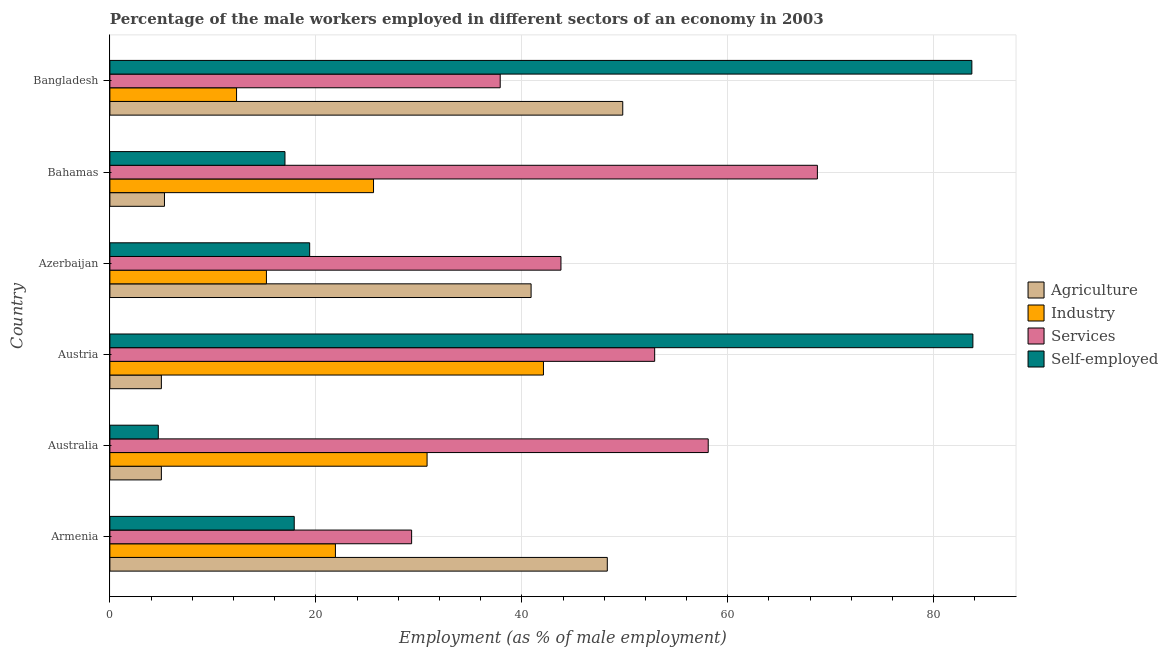How many different coloured bars are there?
Provide a succinct answer. 4. How many groups of bars are there?
Give a very brief answer. 6. Are the number of bars on each tick of the Y-axis equal?
Offer a terse response. Yes. What is the label of the 4th group of bars from the top?
Offer a terse response. Austria. What is the percentage of self employed male workers in Austria?
Your answer should be compact. 83.8. Across all countries, what is the maximum percentage of male workers in services?
Your response must be concise. 68.7. Across all countries, what is the minimum percentage of male workers in industry?
Your answer should be very brief. 12.3. In which country was the percentage of male workers in services maximum?
Keep it short and to the point. Bahamas. What is the total percentage of self employed male workers in the graph?
Offer a very short reply. 226.5. What is the difference between the percentage of self employed male workers in Australia and that in Azerbaijan?
Make the answer very short. -14.7. What is the difference between the percentage of male workers in agriculture in Austria and the percentage of male workers in services in Azerbaijan?
Your answer should be compact. -38.8. What is the average percentage of male workers in services per country?
Offer a very short reply. 48.45. What is the difference between the percentage of male workers in services and percentage of male workers in industry in Bahamas?
Offer a terse response. 43.1. What is the ratio of the percentage of male workers in industry in Austria to that in Azerbaijan?
Your response must be concise. 2.77. Is the difference between the percentage of self employed male workers in Australia and Austria greater than the difference between the percentage of male workers in industry in Australia and Austria?
Make the answer very short. No. What is the difference between the highest and the second highest percentage of male workers in industry?
Offer a very short reply. 11.3. What is the difference between the highest and the lowest percentage of male workers in industry?
Give a very brief answer. 29.8. What does the 2nd bar from the top in Azerbaijan represents?
Give a very brief answer. Services. What does the 1st bar from the bottom in Armenia represents?
Your response must be concise. Agriculture. Is it the case that in every country, the sum of the percentage of male workers in agriculture and percentage of male workers in industry is greater than the percentage of male workers in services?
Your answer should be very brief. No. How many bars are there?
Provide a succinct answer. 24. What is the difference between two consecutive major ticks on the X-axis?
Provide a short and direct response. 20. Are the values on the major ticks of X-axis written in scientific E-notation?
Offer a very short reply. No. Does the graph contain grids?
Keep it short and to the point. Yes. Where does the legend appear in the graph?
Your answer should be very brief. Center right. How are the legend labels stacked?
Your answer should be compact. Vertical. What is the title of the graph?
Your answer should be compact. Percentage of the male workers employed in different sectors of an economy in 2003. What is the label or title of the X-axis?
Your answer should be very brief. Employment (as % of male employment). What is the Employment (as % of male employment) of Agriculture in Armenia?
Provide a short and direct response. 48.3. What is the Employment (as % of male employment) of Industry in Armenia?
Make the answer very short. 21.9. What is the Employment (as % of male employment) of Services in Armenia?
Offer a terse response. 29.3. What is the Employment (as % of male employment) in Self-employed in Armenia?
Your response must be concise. 17.9. What is the Employment (as % of male employment) in Agriculture in Australia?
Offer a very short reply. 5. What is the Employment (as % of male employment) of Industry in Australia?
Provide a short and direct response. 30.8. What is the Employment (as % of male employment) of Services in Australia?
Offer a very short reply. 58.1. What is the Employment (as % of male employment) of Self-employed in Australia?
Give a very brief answer. 4.7. What is the Employment (as % of male employment) of Industry in Austria?
Offer a very short reply. 42.1. What is the Employment (as % of male employment) of Services in Austria?
Ensure brevity in your answer.  52.9. What is the Employment (as % of male employment) in Self-employed in Austria?
Give a very brief answer. 83.8. What is the Employment (as % of male employment) in Agriculture in Azerbaijan?
Your answer should be compact. 40.9. What is the Employment (as % of male employment) in Industry in Azerbaijan?
Your answer should be very brief. 15.2. What is the Employment (as % of male employment) of Services in Azerbaijan?
Give a very brief answer. 43.8. What is the Employment (as % of male employment) of Self-employed in Azerbaijan?
Make the answer very short. 19.4. What is the Employment (as % of male employment) in Agriculture in Bahamas?
Provide a succinct answer. 5.3. What is the Employment (as % of male employment) of Industry in Bahamas?
Your answer should be compact. 25.6. What is the Employment (as % of male employment) in Services in Bahamas?
Your answer should be compact. 68.7. What is the Employment (as % of male employment) in Agriculture in Bangladesh?
Your answer should be very brief. 49.8. What is the Employment (as % of male employment) of Industry in Bangladesh?
Keep it short and to the point. 12.3. What is the Employment (as % of male employment) in Services in Bangladesh?
Your answer should be compact. 37.9. What is the Employment (as % of male employment) in Self-employed in Bangladesh?
Offer a terse response. 83.7. Across all countries, what is the maximum Employment (as % of male employment) in Agriculture?
Offer a terse response. 49.8. Across all countries, what is the maximum Employment (as % of male employment) of Industry?
Make the answer very short. 42.1. Across all countries, what is the maximum Employment (as % of male employment) of Services?
Provide a succinct answer. 68.7. Across all countries, what is the maximum Employment (as % of male employment) of Self-employed?
Provide a short and direct response. 83.8. Across all countries, what is the minimum Employment (as % of male employment) of Industry?
Give a very brief answer. 12.3. Across all countries, what is the minimum Employment (as % of male employment) of Services?
Your response must be concise. 29.3. Across all countries, what is the minimum Employment (as % of male employment) in Self-employed?
Offer a terse response. 4.7. What is the total Employment (as % of male employment) in Agriculture in the graph?
Ensure brevity in your answer.  154.3. What is the total Employment (as % of male employment) of Industry in the graph?
Ensure brevity in your answer.  147.9. What is the total Employment (as % of male employment) in Services in the graph?
Ensure brevity in your answer.  290.7. What is the total Employment (as % of male employment) in Self-employed in the graph?
Provide a succinct answer. 226.5. What is the difference between the Employment (as % of male employment) in Agriculture in Armenia and that in Australia?
Your answer should be very brief. 43.3. What is the difference between the Employment (as % of male employment) in Industry in Armenia and that in Australia?
Your response must be concise. -8.9. What is the difference between the Employment (as % of male employment) in Services in Armenia and that in Australia?
Make the answer very short. -28.8. What is the difference between the Employment (as % of male employment) in Agriculture in Armenia and that in Austria?
Your answer should be compact. 43.3. What is the difference between the Employment (as % of male employment) in Industry in Armenia and that in Austria?
Ensure brevity in your answer.  -20.2. What is the difference between the Employment (as % of male employment) in Services in Armenia and that in Austria?
Keep it short and to the point. -23.6. What is the difference between the Employment (as % of male employment) in Self-employed in Armenia and that in Austria?
Keep it short and to the point. -65.9. What is the difference between the Employment (as % of male employment) in Agriculture in Armenia and that in Azerbaijan?
Your answer should be compact. 7.4. What is the difference between the Employment (as % of male employment) in Industry in Armenia and that in Bahamas?
Your answer should be very brief. -3.7. What is the difference between the Employment (as % of male employment) of Services in Armenia and that in Bahamas?
Ensure brevity in your answer.  -39.4. What is the difference between the Employment (as % of male employment) of Self-employed in Armenia and that in Bahamas?
Offer a very short reply. 0.9. What is the difference between the Employment (as % of male employment) of Industry in Armenia and that in Bangladesh?
Make the answer very short. 9.6. What is the difference between the Employment (as % of male employment) of Services in Armenia and that in Bangladesh?
Give a very brief answer. -8.6. What is the difference between the Employment (as % of male employment) of Self-employed in Armenia and that in Bangladesh?
Offer a terse response. -65.8. What is the difference between the Employment (as % of male employment) in Industry in Australia and that in Austria?
Your answer should be compact. -11.3. What is the difference between the Employment (as % of male employment) of Self-employed in Australia and that in Austria?
Offer a very short reply. -79.1. What is the difference between the Employment (as % of male employment) in Agriculture in Australia and that in Azerbaijan?
Your answer should be compact. -35.9. What is the difference between the Employment (as % of male employment) in Services in Australia and that in Azerbaijan?
Give a very brief answer. 14.3. What is the difference between the Employment (as % of male employment) of Self-employed in Australia and that in Azerbaijan?
Keep it short and to the point. -14.7. What is the difference between the Employment (as % of male employment) of Agriculture in Australia and that in Bahamas?
Provide a short and direct response. -0.3. What is the difference between the Employment (as % of male employment) of Self-employed in Australia and that in Bahamas?
Your answer should be very brief. -12.3. What is the difference between the Employment (as % of male employment) in Agriculture in Australia and that in Bangladesh?
Your answer should be very brief. -44.8. What is the difference between the Employment (as % of male employment) in Services in Australia and that in Bangladesh?
Your response must be concise. 20.2. What is the difference between the Employment (as % of male employment) in Self-employed in Australia and that in Bangladesh?
Ensure brevity in your answer.  -79. What is the difference between the Employment (as % of male employment) in Agriculture in Austria and that in Azerbaijan?
Keep it short and to the point. -35.9. What is the difference between the Employment (as % of male employment) of Industry in Austria and that in Azerbaijan?
Offer a terse response. 26.9. What is the difference between the Employment (as % of male employment) in Self-employed in Austria and that in Azerbaijan?
Your response must be concise. 64.4. What is the difference between the Employment (as % of male employment) of Agriculture in Austria and that in Bahamas?
Ensure brevity in your answer.  -0.3. What is the difference between the Employment (as % of male employment) in Services in Austria and that in Bahamas?
Your answer should be compact. -15.8. What is the difference between the Employment (as % of male employment) in Self-employed in Austria and that in Bahamas?
Provide a succinct answer. 66.8. What is the difference between the Employment (as % of male employment) in Agriculture in Austria and that in Bangladesh?
Your answer should be compact. -44.8. What is the difference between the Employment (as % of male employment) of Industry in Austria and that in Bangladesh?
Keep it short and to the point. 29.8. What is the difference between the Employment (as % of male employment) of Agriculture in Azerbaijan and that in Bahamas?
Provide a succinct answer. 35.6. What is the difference between the Employment (as % of male employment) in Services in Azerbaijan and that in Bahamas?
Make the answer very short. -24.9. What is the difference between the Employment (as % of male employment) in Self-employed in Azerbaijan and that in Bahamas?
Provide a succinct answer. 2.4. What is the difference between the Employment (as % of male employment) of Agriculture in Azerbaijan and that in Bangladesh?
Keep it short and to the point. -8.9. What is the difference between the Employment (as % of male employment) of Self-employed in Azerbaijan and that in Bangladesh?
Give a very brief answer. -64.3. What is the difference between the Employment (as % of male employment) of Agriculture in Bahamas and that in Bangladesh?
Your answer should be very brief. -44.5. What is the difference between the Employment (as % of male employment) in Industry in Bahamas and that in Bangladesh?
Offer a very short reply. 13.3. What is the difference between the Employment (as % of male employment) in Services in Bahamas and that in Bangladesh?
Keep it short and to the point. 30.8. What is the difference between the Employment (as % of male employment) in Self-employed in Bahamas and that in Bangladesh?
Ensure brevity in your answer.  -66.7. What is the difference between the Employment (as % of male employment) of Agriculture in Armenia and the Employment (as % of male employment) of Industry in Australia?
Make the answer very short. 17.5. What is the difference between the Employment (as % of male employment) of Agriculture in Armenia and the Employment (as % of male employment) of Services in Australia?
Give a very brief answer. -9.8. What is the difference between the Employment (as % of male employment) in Agriculture in Armenia and the Employment (as % of male employment) in Self-employed in Australia?
Provide a succinct answer. 43.6. What is the difference between the Employment (as % of male employment) of Industry in Armenia and the Employment (as % of male employment) of Services in Australia?
Ensure brevity in your answer.  -36.2. What is the difference between the Employment (as % of male employment) of Services in Armenia and the Employment (as % of male employment) of Self-employed in Australia?
Offer a very short reply. 24.6. What is the difference between the Employment (as % of male employment) in Agriculture in Armenia and the Employment (as % of male employment) in Industry in Austria?
Your response must be concise. 6.2. What is the difference between the Employment (as % of male employment) of Agriculture in Armenia and the Employment (as % of male employment) of Services in Austria?
Make the answer very short. -4.6. What is the difference between the Employment (as % of male employment) of Agriculture in Armenia and the Employment (as % of male employment) of Self-employed in Austria?
Offer a terse response. -35.5. What is the difference between the Employment (as % of male employment) in Industry in Armenia and the Employment (as % of male employment) in Services in Austria?
Provide a succinct answer. -31. What is the difference between the Employment (as % of male employment) in Industry in Armenia and the Employment (as % of male employment) in Self-employed in Austria?
Provide a succinct answer. -61.9. What is the difference between the Employment (as % of male employment) of Services in Armenia and the Employment (as % of male employment) of Self-employed in Austria?
Give a very brief answer. -54.5. What is the difference between the Employment (as % of male employment) of Agriculture in Armenia and the Employment (as % of male employment) of Industry in Azerbaijan?
Your answer should be very brief. 33.1. What is the difference between the Employment (as % of male employment) in Agriculture in Armenia and the Employment (as % of male employment) in Services in Azerbaijan?
Provide a succinct answer. 4.5. What is the difference between the Employment (as % of male employment) of Agriculture in Armenia and the Employment (as % of male employment) of Self-employed in Azerbaijan?
Make the answer very short. 28.9. What is the difference between the Employment (as % of male employment) in Industry in Armenia and the Employment (as % of male employment) in Services in Azerbaijan?
Offer a very short reply. -21.9. What is the difference between the Employment (as % of male employment) of Industry in Armenia and the Employment (as % of male employment) of Self-employed in Azerbaijan?
Provide a succinct answer. 2.5. What is the difference between the Employment (as % of male employment) of Services in Armenia and the Employment (as % of male employment) of Self-employed in Azerbaijan?
Offer a very short reply. 9.9. What is the difference between the Employment (as % of male employment) in Agriculture in Armenia and the Employment (as % of male employment) in Industry in Bahamas?
Your answer should be compact. 22.7. What is the difference between the Employment (as % of male employment) of Agriculture in Armenia and the Employment (as % of male employment) of Services in Bahamas?
Provide a succinct answer. -20.4. What is the difference between the Employment (as % of male employment) in Agriculture in Armenia and the Employment (as % of male employment) in Self-employed in Bahamas?
Ensure brevity in your answer.  31.3. What is the difference between the Employment (as % of male employment) of Industry in Armenia and the Employment (as % of male employment) of Services in Bahamas?
Your answer should be compact. -46.8. What is the difference between the Employment (as % of male employment) in Industry in Armenia and the Employment (as % of male employment) in Self-employed in Bahamas?
Give a very brief answer. 4.9. What is the difference between the Employment (as % of male employment) in Services in Armenia and the Employment (as % of male employment) in Self-employed in Bahamas?
Make the answer very short. 12.3. What is the difference between the Employment (as % of male employment) of Agriculture in Armenia and the Employment (as % of male employment) of Industry in Bangladesh?
Make the answer very short. 36. What is the difference between the Employment (as % of male employment) of Agriculture in Armenia and the Employment (as % of male employment) of Services in Bangladesh?
Make the answer very short. 10.4. What is the difference between the Employment (as % of male employment) of Agriculture in Armenia and the Employment (as % of male employment) of Self-employed in Bangladesh?
Your answer should be very brief. -35.4. What is the difference between the Employment (as % of male employment) of Industry in Armenia and the Employment (as % of male employment) of Services in Bangladesh?
Ensure brevity in your answer.  -16. What is the difference between the Employment (as % of male employment) in Industry in Armenia and the Employment (as % of male employment) in Self-employed in Bangladesh?
Offer a terse response. -61.8. What is the difference between the Employment (as % of male employment) of Services in Armenia and the Employment (as % of male employment) of Self-employed in Bangladesh?
Your response must be concise. -54.4. What is the difference between the Employment (as % of male employment) in Agriculture in Australia and the Employment (as % of male employment) in Industry in Austria?
Offer a terse response. -37.1. What is the difference between the Employment (as % of male employment) in Agriculture in Australia and the Employment (as % of male employment) in Services in Austria?
Your response must be concise. -47.9. What is the difference between the Employment (as % of male employment) in Agriculture in Australia and the Employment (as % of male employment) in Self-employed in Austria?
Offer a very short reply. -78.8. What is the difference between the Employment (as % of male employment) in Industry in Australia and the Employment (as % of male employment) in Services in Austria?
Offer a terse response. -22.1. What is the difference between the Employment (as % of male employment) in Industry in Australia and the Employment (as % of male employment) in Self-employed in Austria?
Keep it short and to the point. -53. What is the difference between the Employment (as % of male employment) of Services in Australia and the Employment (as % of male employment) of Self-employed in Austria?
Make the answer very short. -25.7. What is the difference between the Employment (as % of male employment) in Agriculture in Australia and the Employment (as % of male employment) in Services in Azerbaijan?
Keep it short and to the point. -38.8. What is the difference between the Employment (as % of male employment) of Agriculture in Australia and the Employment (as % of male employment) of Self-employed in Azerbaijan?
Make the answer very short. -14.4. What is the difference between the Employment (as % of male employment) in Industry in Australia and the Employment (as % of male employment) in Self-employed in Azerbaijan?
Keep it short and to the point. 11.4. What is the difference between the Employment (as % of male employment) of Services in Australia and the Employment (as % of male employment) of Self-employed in Azerbaijan?
Give a very brief answer. 38.7. What is the difference between the Employment (as % of male employment) in Agriculture in Australia and the Employment (as % of male employment) in Industry in Bahamas?
Provide a short and direct response. -20.6. What is the difference between the Employment (as % of male employment) in Agriculture in Australia and the Employment (as % of male employment) in Services in Bahamas?
Keep it short and to the point. -63.7. What is the difference between the Employment (as % of male employment) of Agriculture in Australia and the Employment (as % of male employment) of Self-employed in Bahamas?
Make the answer very short. -12. What is the difference between the Employment (as % of male employment) in Industry in Australia and the Employment (as % of male employment) in Services in Bahamas?
Make the answer very short. -37.9. What is the difference between the Employment (as % of male employment) of Services in Australia and the Employment (as % of male employment) of Self-employed in Bahamas?
Provide a succinct answer. 41.1. What is the difference between the Employment (as % of male employment) of Agriculture in Australia and the Employment (as % of male employment) of Services in Bangladesh?
Your answer should be very brief. -32.9. What is the difference between the Employment (as % of male employment) in Agriculture in Australia and the Employment (as % of male employment) in Self-employed in Bangladesh?
Your answer should be compact. -78.7. What is the difference between the Employment (as % of male employment) in Industry in Australia and the Employment (as % of male employment) in Services in Bangladesh?
Your answer should be very brief. -7.1. What is the difference between the Employment (as % of male employment) in Industry in Australia and the Employment (as % of male employment) in Self-employed in Bangladesh?
Your answer should be compact. -52.9. What is the difference between the Employment (as % of male employment) of Services in Australia and the Employment (as % of male employment) of Self-employed in Bangladesh?
Your answer should be compact. -25.6. What is the difference between the Employment (as % of male employment) of Agriculture in Austria and the Employment (as % of male employment) of Services in Azerbaijan?
Provide a short and direct response. -38.8. What is the difference between the Employment (as % of male employment) in Agriculture in Austria and the Employment (as % of male employment) in Self-employed in Azerbaijan?
Provide a short and direct response. -14.4. What is the difference between the Employment (as % of male employment) of Industry in Austria and the Employment (as % of male employment) of Self-employed in Azerbaijan?
Keep it short and to the point. 22.7. What is the difference between the Employment (as % of male employment) in Services in Austria and the Employment (as % of male employment) in Self-employed in Azerbaijan?
Offer a terse response. 33.5. What is the difference between the Employment (as % of male employment) in Agriculture in Austria and the Employment (as % of male employment) in Industry in Bahamas?
Make the answer very short. -20.6. What is the difference between the Employment (as % of male employment) of Agriculture in Austria and the Employment (as % of male employment) of Services in Bahamas?
Your answer should be compact. -63.7. What is the difference between the Employment (as % of male employment) of Agriculture in Austria and the Employment (as % of male employment) of Self-employed in Bahamas?
Provide a succinct answer. -12. What is the difference between the Employment (as % of male employment) of Industry in Austria and the Employment (as % of male employment) of Services in Bahamas?
Your response must be concise. -26.6. What is the difference between the Employment (as % of male employment) in Industry in Austria and the Employment (as % of male employment) in Self-employed in Bahamas?
Your response must be concise. 25.1. What is the difference between the Employment (as % of male employment) of Services in Austria and the Employment (as % of male employment) of Self-employed in Bahamas?
Make the answer very short. 35.9. What is the difference between the Employment (as % of male employment) of Agriculture in Austria and the Employment (as % of male employment) of Services in Bangladesh?
Ensure brevity in your answer.  -32.9. What is the difference between the Employment (as % of male employment) in Agriculture in Austria and the Employment (as % of male employment) in Self-employed in Bangladesh?
Your response must be concise. -78.7. What is the difference between the Employment (as % of male employment) in Industry in Austria and the Employment (as % of male employment) in Self-employed in Bangladesh?
Keep it short and to the point. -41.6. What is the difference between the Employment (as % of male employment) in Services in Austria and the Employment (as % of male employment) in Self-employed in Bangladesh?
Provide a short and direct response. -30.8. What is the difference between the Employment (as % of male employment) of Agriculture in Azerbaijan and the Employment (as % of male employment) of Services in Bahamas?
Your answer should be very brief. -27.8. What is the difference between the Employment (as % of male employment) in Agriculture in Azerbaijan and the Employment (as % of male employment) in Self-employed in Bahamas?
Give a very brief answer. 23.9. What is the difference between the Employment (as % of male employment) of Industry in Azerbaijan and the Employment (as % of male employment) of Services in Bahamas?
Offer a very short reply. -53.5. What is the difference between the Employment (as % of male employment) of Services in Azerbaijan and the Employment (as % of male employment) of Self-employed in Bahamas?
Offer a terse response. 26.8. What is the difference between the Employment (as % of male employment) of Agriculture in Azerbaijan and the Employment (as % of male employment) of Industry in Bangladesh?
Give a very brief answer. 28.6. What is the difference between the Employment (as % of male employment) of Agriculture in Azerbaijan and the Employment (as % of male employment) of Self-employed in Bangladesh?
Your response must be concise. -42.8. What is the difference between the Employment (as % of male employment) in Industry in Azerbaijan and the Employment (as % of male employment) in Services in Bangladesh?
Provide a succinct answer. -22.7. What is the difference between the Employment (as % of male employment) of Industry in Azerbaijan and the Employment (as % of male employment) of Self-employed in Bangladesh?
Your response must be concise. -68.5. What is the difference between the Employment (as % of male employment) of Services in Azerbaijan and the Employment (as % of male employment) of Self-employed in Bangladesh?
Keep it short and to the point. -39.9. What is the difference between the Employment (as % of male employment) in Agriculture in Bahamas and the Employment (as % of male employment) in Services in Bangladesh?
Give a very brief answer. -32.6. What is the difference between the Employment (as % of male employment) of Agriculture in Bahamas and the Employment (as % of male employment) of Self-employed in Bangladesh?
Provide a succinct answer. -78.4. What is the difference between the Employment (as % of male employment) in Industry in Bahamas and the Employment (as % of male employment) in Services in Bangladesh?
Offer a terse response. -12.3. What is the difference between the Employment (as % of male employment) in Industry in Bahamas and the Employment (as % of male employment) in Self-employed in Bangladesh?
Provide a short and direct response. -58.1. What is the difference between the Employment (as % of male employment) in Services in Bahamas and the Employment (as % of male employment) in Self-employed in Bangladesh?
Your response must be concise. -15. What is the average Employment (as % of male employment) of Agriculture per country?
Give a very brief answer. 25.72. What is the average Employment (as % of male employment) of Industry per country?
Provide a short and direct response. 24.65. What is the average Employment (as % of male employment) in Services per country?
Offer a very short reply. 48.45. What is the average Employment (as % of male employment) in Self-employed per country?
Your response must be concise. 37.75. What is the difference between the Employment (as % of male employment) of Agriculture and Employment (as % of male employment) of Industry in Armenia?
Provide a short and direct response. 26.4. What is the difference between the Employment (as % of male employment) of Agriculture and Employment (as % of male employment) of Self-employed in Armenia?
Ensure brevity in your answer.  30.4. What is the difference between the Employment (as % of male employment) in Industry and Employment (as % of male employment) in Services in Armenia?
Ensure brevity in your answer.  -7.4. What is the difference between the Employment (as % of male employment) of Industry and Employment (as % of male employment) of Self-employed in Armenia?
Keep it short and to the point. 4. What is the difference between the Employment (as % of male employment) of Services and Employment (as % of male employment) of Self-employed in Armenia?
Your answer should be very brief. 11.4. What is the difference between the Employment (as % of male employment) of Agriculture and Employment (as % of male employment) of Industry in Australia?
Provide a succinct answer. -25.8. What is the difference between the Employment (as % of male employment) in Agriculture and Employment (as % of male employment) in Services in Australia?
Offer a very short reply. -53.1. What is the difference between the Employment (as % of male employment) in Agriculture and Employment (as % of male employment) in Self-employed in Australia?
Keep it short and to the point. 0.3. What is the difference between the Employment (as % of male employment) of Industry and Employment (as % of male employment) of Services in Australia?
Your answer should be very brief. -27.3. What is the difference between the Employment (as % of male employment) of Industry and Employment (as % of male employment) of Self-employed in Australia?
Give a very brief answer. 26.1. What is the difference between the Employment (as % of male employment) in Services and Employment (as % of male employment) in Self-employed in Australia?
Give a very brief answer. 53.4. What is the difference between the Employment (as % of male employment) of Agriculture and Employment (as % of male employment) of Industry in Austria?
Your answer should be compact. -37.1. What is the difference between the Employment (as % of male employment) of Agriculture and Employment (as % of male employment) of Services in Austria?
Offer a very short reply. -47.9. What is the difference between the Employment (as % of male employment) of Agriculture and Employment (as % of male employment) of Self-employed in Austria?
Provide a short and direct response. -78.8. What is the difference between the Employment (as % of male employment) in Industry and Employment (as % of male employment) in Services in Austria?
Your answer should be very brief. -10.8. What is the difference between the Employment (as % of male employment) in Industry and Employment (as % of male employment) in Self-employed in Austria?
Make the answer very short. -41.7. What is the difference between the Employment (as % of male employment) in Services and Employment (as % of male employment) in Self-employed in Austria?
Your answer should be very brief. -30.9. What is the difference between the Employment (as % of male employment) in Agriculture and Employment (as % of male employment) in Industry in Azerbaijan?
Your answer should be very brief. 25.7. What is the difference between the Employment (as % of male employment) in Agriculture and Employment (as % of male employment) in Services in Azerbaijan?
Make the answer very short. -2.9. What is the difference between the Employment (as % of male employment) in Agriculture and Employment (as % of male employment) in Self-employed in Azerbaijan?
Offer a very short reply. 21.5. What is the difference between the Employment (as % of male employment) of Industry and Employment (as % of male employment) of Services in Azerbaijan?
Offer a very short reply. -28.6. What is the difference between the Employment (as % of male employment) of Services and Employment (as % of male employment) of Self-employed in Azerbaijan?
Make the answer very short. 24.4. What is the difference between the Employment (as % of male employment) of Agriculture and Employment (as % of male employment) of Industry in Bahamas?
Ensure brevity in your answer.  -20.3. What is the difference between the Employment (as % of male employment) of Agriculture and Employment (as % of male employment) of Services in Bahamas?
Make the answer very short. -63.4. What is the difference between the Employment (as % of male employment) of Agriculture and Employment (as % of male employment) of Self-employed in Bahamas?
Offer a very short reply. -11.7. What is the difference between the Employment (as % of male employment) in Industry and Employment (as % of male employment) in Services in Bahamas?
Your response must be concise. -43.1. What is the difference between the Employment (as % of male employment) in Services and Employment (as % of male employment) in Self-employed in Bahamas?
Keep it short and to the point. 51.7. What is the difference between the Employment (as % of male employment) in Agriculture and Employment (as % of male employment) in Industry in Bangladesh?
Offer a very short reply. 37.5. What is the difference between the Employment (as % of male employment) in Agriculture and Employment (as % of male employment) in Self-employed in Bangladesh?
Offer a terse response. -33.9. What is the difference between the Employment (as % of male employment) of Industry and Employment (as % of male employment) of Services in Bangladesh?
Ensure brevity in your answer.  -25.6. What is the difference between the Employment (as % of male employment) of Industry and Employment (as % of male employment) of Self-employed in Bangladesh?
Your answer should be very brief. -71.4. What is the difference between the Employment (as % of male employment) in Services and Employment (as % of male employment) in Self-employed in Bangladesh?
Give a very brief answer. -45.8. What is the ratio of the Employment (as % of male employment) of Agriculture in Armenia to that in Australia?
Give a very brief answer. 9.66. What is the ratio of the Employment (as % of male employment) in Industry in Armenia to that in Australia?
Offer a very short reply. 0.71. What is the ratio of the Employment (as % of male employment) of Services in Armenia to that in Australia?
Keep it short and to the point. 0.5. What is the ratio of the Employment (as % of male employment) in Self-employed in Armenia to that in Australia?
Your response must be concise. 3.81. What is the ratio of the Employment (as % of male employment) in Agriculture in Armenia to that in Austria?
Offer a terse response. 9.66. What is the ratio of the Employment (as % of male employment) in Industry in Armenia to that in Austria?
Your response must be concise. 0.52. What is the ratio of the Employment (as % of male employment) of Services in Armenia to that in Austria?
Make the answer very short. 0.55. What is the ratio of the Employment (as % of male employment) in Self-employed in Armenia to that in Austria?
Ensure brevity in your answer.  0.21. What is the ratio of the Employment (as % of male employment) of Agriculture in Armenia to that in Azerbaijan?
Provide a short and direct response. 1.18. What is the ratio of the Employment (as % of male employment) of Industry in Armenia to that in Azerbaijan?
Provide a short and direct response. 1.44. What is the ratio of the Employment (as % of male employment) of Services in Armenia to that in Azerbaijan?
Your response must be concise. 0.67. What is the ratio of the Employment (as % of male employment) in Self-employed in Armenia to that in Azerbaijan?
Offer a terse response. 0.92. What is the ratio of the Employment (as % of male employment) of Agriculture in Armenia to that in Bahamas?
Provide a succinct answer. 9.11. What is the ratio of the Employment (as % of male employment) of Industry in Armenia to that in Bahamas?
Ensure brevity in your answer.  0.86. What is the ratio of the Employment (as % of male employment) of Services in Armenia to that in Bahamas?
Your response must be concise. 0.43. What is the ratio of the Employment (as % of male employment) in Self-employed in Armenia to that in Bahamas?
Your answer should be compact. 1.05. What is the ratio of the Employment (as % of male employment) of Agriculture in Armenia to that in Bangladesh?
Your answer should be very brief. 0.97. What is the ratio of the Employment (as % of male employment) of Industry in Armenia to that in Bangladesh?
Your response must be concise. 1.78. What is the ratio of the Employment (as % of male employment) in Services in Armenia to that in Bangladesh?
Ensure brevity in your answer.  0.77. What is the ratio of the Employment (as % of male employment) of Self-employed in Armenia to that in Bangladesh?
Keep it short and to the point. 0.21. What is the ratio of the Employment (as % of male employment) in Agriculture in Australia to that in Austria?
Ensure brevity in your answer.  1. What is the ratio of the Employment (as % of male employment) of Industry in Australia to that in Austria?
Provide a succinct answer. 0.73. What is the ratio of the Employment (as % of male employment) of Services in Australia to that in Austria?
Your response must be concise. 1.1. What is the ratio of the Employment (as % of male employment) of Self-employed in Australia to that in Austria?
Your response must be concise. 0.06. What is the ratio of the Employment (as % of male employment) of Agriculture in Australia to that in Azerbaijan?
Your answer should be very brief. 0.12. What is the ratio of the Employment (as % of male employment) in Industry in Australia to that in Azerbaijan?
Your answer should be compact. 2.03. What is the ratio of the Employment (as % of male employment) of Services in Australia to that in Azerbaijan?
Your answer should be very brief. 1.33. What is the ratio of the Employment (as % of male employment) of Self-employed in Australia to that in Azerbaijan?
Your answer should be compact. 0.24. What is the ratio of the Employment (as % of male employment) of Agriculture in Australia to that in Bahamas?
Give a very brief answer. 0.94. What is the ratio of the Employment (as % of male employment) in Industry in Australia to that in Bahamas?
Provide a succinct answer. 1.2. What is the ratio of the Employment (as % of male employment) of Services in Australia to that in Bahamas?
Your response must be concise. 0.85. What is the ratio of the Employment (as % of male employment) in Self-employed in Australia to that in Bahamas?
Offer a very short reply. 0.28. What is the ratio of the Employment (as % of male employment) of Agriculture in Australia to that in Bangladesh?
Your response must be concise. 0.1. What is the ratio of the Employment (as % of male employment) in Industry in Australia to that in Bangladesh?
Your response must be concise. 2.5. What is the ratio of the Employment (as % of male employment) of Services in Australia to that in Bangladesh?
Offer a very short reply. 1.53. What is the ratio of the Employment (as % of male employment) in Self-employed in Australia to that in Bangladesh?
Your response must be concise. 0.06. What is the ratio of the Employment (as % of male employment) of Agriculture in Austria to that in Azerbaijan?
Give a very brief answer. 0.12. What is the ratio of the Employment (as % of male employment) of Industry in Austria to that in Azerbaijan?
Offer a very short reply. 2.77. What is the ratio of the Employment (as % of male employment) of Services in Austria to that in Azerbaijan?
Ensure brevity in your answer.  1.21. What is the ratio of the Employment (as % of male employment) in Self-employed in Austria to that in Azerbaijan?
Offer a terse response. 4.32. What is the ratio of the Employment (as % of male employment) in Agriculture in Austria to that in Bahamas?
Offer a very short reply. 0.94. What is the ratio of the Employment (as % of male employment) in Industry in Austria to that in Bahamas?
Give a very brief answer. 1.64. What is the ratio of the Employment (as % of male employment) in Services in Austria to that in Bahamas?
Your answer should be very brief. 0.77. What is the ratio of the Employment (as % of male employment) in Self-employed in Austria to that in Bahamas?
Give a very brief answer. 4.93. What is the ratio of the Employment (as % of male employment) in Agriculture in Austria to that in Bangladesh?
Make the answer very short. 0.1. What is the ratio of the Employment (as % of male employment) in Industry in Austria to that in Bangladesh?
Provide a succinct answer. 3.42. What is the ratio of the Employment (as % of male employment) of Services in Austria to that in Bangladesh?
Give a very brief answer. 1.4. What is the ratio of the Employment (as % of male employment) of Agriculture in Azerbaijan to that in Bahamas?
Keep it short and to the point. 7.72. What is the ratio of the Employment (as % of male employment) of Industry in Azerbaijan to that in Bahamas?
Your answer should be compact. 0.59. What is the ratio of the Employment (as % of male employment) in Services in Azerbaijan to that in Bahamas?
Keep it short and to the point. 0.64. What is the ratio of the Employment (as % of male employment) of Self-employed in Azerbaijan to that in Bahamas?
Keep it short and to the point. 1.14. What is the ratio of the Employment (as % of male employment) of Agriculture in Azerbaijan to that in Bangladesh?
Provide a short and direct response. 0.82. What is the ratio of the Employment (as % of male employment) in Industry in Azerbaijan to that in Bangladesh?
Your response must be concise. 1.24. What is the ratio of the Employment (as % of male employment) in Services in Azerbaijan to that in Bangladesh?
Provide a succinct answer. 1.16. What is the ratio of the Employment (as % of male employment) in Self-employed in Azerbaijan to that in Bangladesh?
Offer a terse response. 0.23. What is the ratio of the Employment (as % of male employment) of Agriculture in Bahamas to that in Bangladesh?
Keep it short and to the point. 0.11. What is the ratio of the Employment (as % of male employment) of Industry in Bahamas to that in Bangladesh?
Make the answer very short. 2.08. What is the ratio of the Employment (as % of male employment) of Services in Bahamas to that in Bangladesh?
Make the answer very short. 1.81. What is the ratio of the Employment (as % of male employment) of Self-employed in Bahamas to that in Bangladesh?
Provide a short and direct response. 0.2. What is the difference between the highest and the lowest Employment (as % of male employment) of Agriculture?
Make the answer very short. 44.8. What is the difference between the highest and the lowest Employment (as % of male employment) of Industry?
Give a very brief answer. 29.8. What is the difference between the highest and the lowest Employment (as % of male employment) of Services?
Your answer should be very brief. 39.4. What is the difference between the highest and the lowest Employment (as % of male employment) of Self-employed?
Keep it short and to the point. 79.1. 